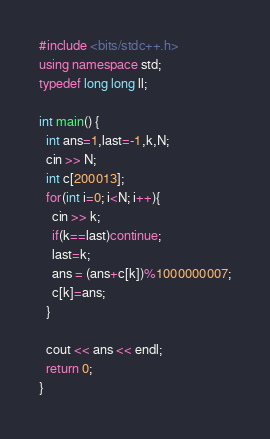Convert code to text. <code><loc_0><loc_0><loc_500><loc_500><_C++_>#include <bits/stdc++.h>
using namespace std;
typedef long long ll;

int main() {
  int ans=1,last=-1,k,N;
  cin >> N;
  int c[200013];
  for(int i=0; i<N; i++){
    cin >> k;
    if(k==last)continue;
    last=k;
    ans = (ans+c[k])%1000000007;
    c[k]=ans;
  }

  cout << ans << endl;
  return 0;
}</code> 